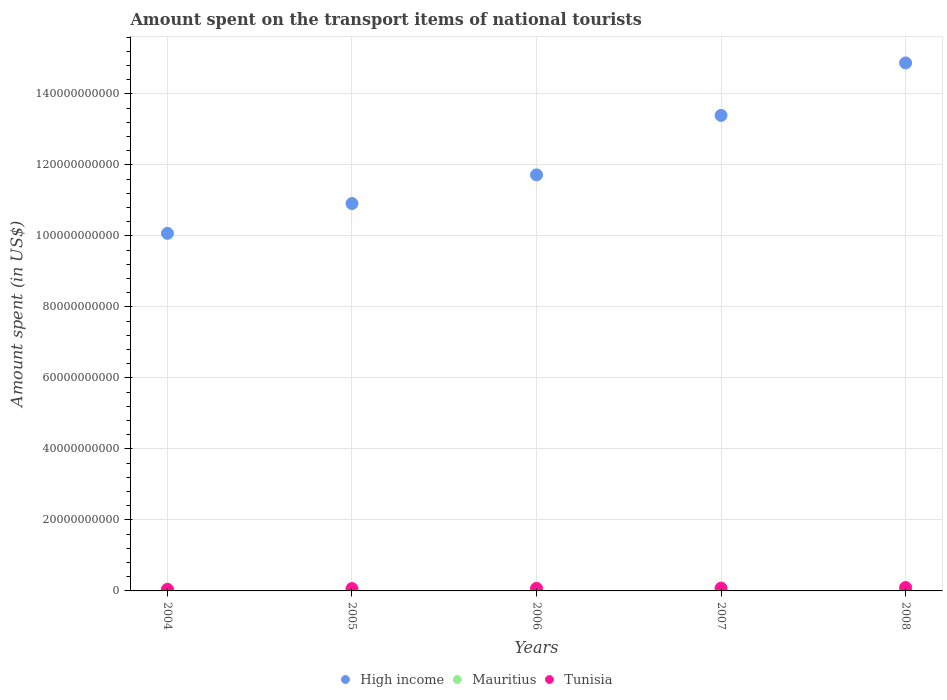How many different coloured dotlines are there?
Your answer should be compact. 3. What is the amount spent on the transport items of national tourists in Tunisia in 2007?
Provide a succinct answer. 7.98e+08. Across all years, what is the maximum amount spent on the transport items of national tourists in Tunisia?
Your response must be concise. 9.56e+08. Across all years, what is the minimum amount spent on the transport items of national tourists in High income?
Your answer should be very brief. 1.01e+11. In which year was the amount spent on the transport items of national tourists in High income maximum?
Offer a very short reply. 2008. What is the total amount spent on the transport items of national tourists in Mauritius in the graph?
Make the answer very short. 1.64e+09. What is the difference between the amount spent on the transport items of national tourists in Mauritius in 2004 and that in 2008?
Your answer should be very brief. -6.90e+07. What is the difference between the amount spent on the transport items of national tourists in Tunisia in 2006 and the amount spent on the transport items of national tourists in Mauritius in 2004?
Your response must be concise. 4.24e+08. What is the average amount spent on the transport items of national tourists in High income per year?
Provide a succinct answer. 1.22e+11. In the year 2007, what is the difference between the amount spent on the transport items of national tourists in Mauritius and amount spent on the transport items of national tourists in Tunisia?
Make the answer very short. -4.39e+08. What is the ratio of the amount spent on the transport items of national tourists in High income in 2006 to that in 2007?
Keep it short and to the point. 0.87. Is the amount spent on the transport items of national tourists in Mauritius in 2006 less than that in 2007?
Ensure brevity in your answer.  Yes. Is the difference between the amount spent on the transport items of national tourists in Mauritius in 2006 and 2007 greater than the difference between the amount spent on the transport items of national tourists in Tunisia in 2006 and 2007?
Give a very brief answer. Yes. What is the difference between the highest and the second highest amount spent on the transport items of national tourists in High income?
Your response must be concise. 1.48e+1. What is the difference between the highest and the lowest amount spent on the transport items of national tourists in Tunisia?
Provide a succinct answer. 4.94e+08. In how many years, is the amount spent on the transport items of national tourists in Mauritius greater than the average amount spent on the transport items of national tourists in Mauritius taken over all years?
Ensure brevity in your answer.  2. Is the sum of the amount spent on the transport items of national tourists in High income in 2005 and 2006 greater than the maximum amount spent on the transport items of national tourists in Tunisia across all years?
Keep it short and to the point. Yes. How many dotlines are there?
Give a very brief answer. 3. How many years are there in the graph?
Your answer should be very brief. 5. What is the difference between two consecutive major ticks on the Y-axis?
Provide a succinct answer. 2.00e+1. Are the values on the major ticks of Y-axis written in scientific E-notation?
Your response must be concise. No. Does the graph contain grids?
Offer a terse response. Yes. Where does the legend appear in the graph?
Keep it short and to the point. Bottom center. What is the title of the graph?
Give a very brief answer. Amount spent on the transport items of national tourists. Does "South Sudan" appear as one of the legend labels in the graph?
Provide a succinct answer. No. What is the label or title of the Y-axis?
Provide a succinct answer. Amount spent (in US$). What is the Amount spent (in US$) of High income in 2004?
Make the answer very short. 1.01e+11. What is the Amount spent (in US$) in Mauritius in 2004?
Give a very brief answer. 3.00e+08. What is the Amount spent (in US$) in Tunisia in 2004?
Give a very brief answer. 4.62e+08. What is the Amount spent (in US$) in High income in 2005?
Offer a very short reply. 1.09e+11. What is the Amount spent (in US$) of Mauritius in 2005?
Provide a succinct answer. 3.18e+08. What is the Amount spent (in US$) of Tunisia in 2005?
Provide a succinct answer. 6.57e+08. What is the Amount spent (in US$) of High income in 2006?
Provide a succinct answer. 1.17e+11. What is the Amount spent (in US$) in Mauritius in 2006?
Your response must be concise. 2.97e+08. What is the Amount spent (in US$) of Tunisia in 2006?
Offer a terse response. 7.24e+08. What is the Amount spent (in US$) in High income in 2007?
Keep it short and to the point. 1.34e+11. What is the Amount spent (in US$) of Mauritius in 2007?
Offer a very short reply. 3.59e+08. What is the Amount spent (in US$) of Tunisia in 2007?
Keep it short and to the point. 7.98e+08. What is the Amount spent (in US$) of High income in 2008?
Give a very brief answer. 1.49e+11. What is the Amount spent (in US$) of Mauritius in 2008?
Give a very brief answer. 3.69e+08. What is the Amount spent (in US$) in Tunisia in 2008?
Provide a short and direct response. 9.56e+08. Across all years, what is the maximum Amount spent (in US$) in High income?
Provide a short and direct response. 1.49e+11. Across all years, what is the maximum Amount spent (in US$) of Mauritius?
Your answer should be very brief. 3.69e+08. Across all years, what is the maximum Amount spent (in US$) of Tunisia?
Make the answer very short. 9.56e+08. Across all years, what is the minimum Amount spent (in US$) in High income?
Provide a succinct answer. 1.01e+11. Across all years, what is the minimum Amount spent (in US$) of Mauritius?
Your answer should be compact. 2.97e+08. Across all years, what is the minimum Amount spent (in US$) in Tunisia?
Make the answer very short. 4.62e+08. What is the total Amount spent (in US$) in High income in the graph?
Provide a succinct answer. 6.10e+11. What is the total Amount spent (in US$) of Mauritius in the graph?
Ensure brevity in your answer.  1.64e+09. What is the total Amount spent (in US$) of Tunisia in the graph?
Provide a succinct answer. 3.60e+09. What is the difference between the Amount spent (in US$) of High income in 2004 and that in 2005?
Ensure brevity in your answer.  -8.40e+09. What is the difference between the Amount spent (in US$) of Mauritius in 2004 and that in 2005?
Provide a short and direct response. -1.80e+07. What is the difference between the Amount spent (in US$) in Tunisia in 2004 and that in 2005?
Provide a succinct answer. -1.95e+08. What is the difference between the Amount spent (in US$) of High income in 2004 and that in 2006?
Provide a short and direct response. -1.65e+1. What is the difference between the Amount spent (in US$) of Mauritius in 2004 and that in 2006?
Provide a short and direct response. 3.00e+06. What is the difference between the Amount spent (in US$) in Tunisia in 2004 and that in 2006?
Your answer should be very brief. -2.62e+08. What is the difference between the Amount spent (in US$) in High income in 2004 and that in 2007?
Offer a very short reply. -3.32e+1. What is the difference between the Amount spent (in US$) in Mauritius in 2004 and that in 2007?
Keep it short and to the point. -5.90e+07. What is the difference between the Amount spent (in US$) in Tunisia in 2004 and that in 2007?
Provide a short and direct response. -3.36e+08. What is the difference between the Amount spent (in US$) of High income in 2004 and that in 2008?
Ensure brevity in your answer.  -4.80e+1. What is the difference between the Amount spent (in US$) in Mauritius in 2004 and that in 2008?
Offer a very short reply. -6.90e+07. What is the difference between the Amount spent (in US$) in Tunisia in 2004 and that in 2008?
Provide a succinct answer. -4.94e+08. What is the difference between the Amount spent (in US$) in High income in 2005 and that in 2006?
Make the answer very short. -8.07e+09. What is the difference between the Amount spent (in US$) of Mauritius in 2005 and that in 2006?
Make the answer very short. 2.10e+07. What is the difference between the Amount spent (in US$) in Tunisia in 2005 and that in 2006?
Your response must be concise. -6.70e+07. What is the difference between the Amount spent (in US$) of High income in 2005 and that in 2007?
Your answer should be compact. -2.48e+1. What is the difference between the Amount spent (in US$) in Mauritius in 2005 and that in 2007?
Your answer should be compact. -4.10e+07. What is the difference between the Amount spent (in US$) of Tunisia in 2005 and that in 2007?
Provide a short and direct response. -1.41e+08. What is the difference between the Amount spent (in US$) in High income in 2005 and that in 2008?
Give a very brief answer. -3.96e+1. What is the difference between the Amount spent (in US$) in Mauritius in 2005 and that in 2008?
Offer a terse response. -5.10e+07. What is the difference between the Amount spent (in US$) in Tunisia in 2005 and that in 2008?
Offer a terse response. -2.99e+08. What is the difference between the Amount spent (in US$) in High income in 2006 and that in 2007?
Your answer should be compact. -1.68e+1. What is the difference between the Amount spent (in US$) in Mauritius in 2006 and that in 2007?
Your response must be concise. -6.20e+07. What is the difference between the Amount spent (in US$) in Tunisia in 2006 and that in 2007?
Ensure brevity in your answer.  -7.40e+07. What is the difference between the Amount spent (in US$) of High income in 2006 and that in 2008?
Provide a short and direct response. -3.15e+1. What is the difference between the Amount spent (in US$) of Mauritius in 2006 and that in 2008?
Provide a succinct answer. -7.20e+07. What is the difference between the Amount spent (in US$) in Tunisia in 2006 and that in 2008?
Your answer should be very brief. -2.32e+08. What is the difference between the Amount spent (in US$) in High income in 2007 and that in 2008?
Offer a very short reply. -1.48e+1. What is the difference between the Amount spent (in US$) in Mauritius in 2007 and that in 2008?
Your answer should be compact. -1.00e+07. What is the difference between the Amount spent (in US$) in Tunisia in 2007 and that in 2008?
Make the answer very short. -1.58e+08. What is the difference between the Amount spent (in US$) of High income in 2004 and the Amount spent (in US$) of Mauritius in 2005?
Provide a short and direct response. 1.00e+11. What is the difference between the Amount spent (in US$) in High income in 2004 and the Amount spent (in US$) in Tunisia in 2005?
Offer a terse response. 1.00e+11. What is the difference between the Amount spent (in US$) in Mauritius in 2004 and the Amount spent (in US$) in Tunisia in 2005?
Offer a very short reply. -3.57e+08. What is the difference between the Amount spent (in US$) in High income in 2004 and the Amount spent (in US$) in Mauritius in 2006?
Give a very brief answer. 1.00e+11. What is the difference between the Amount spent (in US$) in High income in 2004 and the Amount spent (in US$) in Tunisia in 2006?
Give a very brief answer. 1.00e+11. What is the difference between the Amount spent (in US$) in Mauritius in 2004 and the Amount spent (in US$) in Tunisia in 2006?
Your answer should be compact. -4.24e+08. What is the difference between the Amount spent (in US$) of High income in 2004 and the Amount spent (in US$) of Mauritius in 2007?
Give a very brief answer. 1.00e+11. What is the difference between the Amount spent (in US$) of High income in 2004 and the Amount spent (in US$) of Tunisia in 2007?
Keep it short and to the point. 9.99e+1. What is the difference between the Amount spent (in US$) of Mauritius in 2004 and the Amount spent (in US$) of Tunisia in 2007?
Offer a very short reply. -4.98e+08. What is the difference between the Amount spent (in US$) in High income in 2004 and the Amount spent (in US$) in Mauritius in 2008?
Offer a terse response. 1.00e+11. What is the difference between the Amount spent (in US$) in High income in 2004 and the Amount spent (in US$) in Tunisia in 2008?
Give a very brief answer. 9.98e+1. What is the difference between the Amount spent (in US$) of Mauritius in 2004 and the Amount spent (in US$) of Tunisia in 2008?
Provide a succinct answer. -6.56e+08. What is the difference between the Amount spent (in US$) of High income in 2005 and the Amount spent (in US$) of Mauritius in 2006?
Your response must be concise. 1.09e+11. What is the difference between the Amount spent (in US$) of High income in 2005 and the Amount spent (in US$) of Tunisia in 2006?
Your answer should be very brief. 1.08e+11. What is the difference between the Amount spent (in US$) in Mauritius in 2005 and the Amount spent (in US$) in Tunisia in 2006?
Offer a terse response. -4.06e+08. What is the difference between the Amount spent (in US$) of High income in 2005 and the Amount spent (in US$) of Mauritius in 2007?
Provide a succinct answer. 1.09e+11. What is the difference between the Amount spent (in US$) in High income in 2005 and the Amount spent (in US$) in Tunisia in 2007?
Your response must be concise. 1.08e+11. What is the difference between the Amount spent (in US$) of Mauritius in 2005 and the Amount spent (in US$) of Tunisia in 2007?
Your answer should be compact. -4.80e+08. What is the difference between the Amount spent (in US$) of High income in 2005 and the Amount spent (in US$) of Mauritius in 2008?
Your response must be concise. 1.09e+11. What is the difference between the Amount spent (in US$) in High income in 2005 and the Amount spent (in US$) in Tunisia in 2008?
Offer a terse response. 1.08e+11. What is the difference between the Amount spent (in US$) of Mauritius in 2005 and the Amount spent (in US$) of Tunisia in 2008?
Offer a very short reply. -6.38e+08. What is the difference between the Amount spent (in US$) of High income in 2006 and the Amount spent (in US$) of Mauritius in 2007?
Ensure brevity in your answer.  1.17e+11. What is the difference between the Amount spent (in US$) of High income in 2006 and the Amount spent (in US$) of Tunisia in 2007?
Make the answer very short. 1.16e+11. What is the difference between the Amount spent (in US$) in Mauritius in 2006 and the Amount spent (in US$) in Tunisia in 2007?
Keep it short and to the point. -5.01e+08. What is the difference between the Amount spent (in US$) in High income in 2006 and the Amount spent (in US$) in Mauritius in 2008?
Give a very brief answer. 1.17e+11. What is the difference between the Amount spent (in US$) of High income in 2006 and the Amount spent (in US$) of Tunisia in 2008?
Your answer should be very brief. 1.16e+11. What is the difference between the Amount spent (in US$) in Mauritius in 2006 and the Amount spent (in US$) in Tunisia in 2008?
Make the answer very short. -6.59e+08. What is the difference between the Amount spent (in US$) of High income in 2007 and the Amount spent (in US$) of Mauritius in 2008?
Provide a short and direct response. 1.34e+11. What is the difference between the Amount spent (in US$) of High income in 2007 and the Amount spent (in US$) of Tunisia in 2008?
Offer a terse response. 1.33e+11. What is the difference between the Amount spent (in US$) of Mauritius in 2007 and the Amount spent (in US$) of Tunisia in 2008?
Give a very brief answer. -5.97e+08. What is the average Amount spent (in US$) in High income per year?
Ensure brevity in your answer.  1.22e+11. What is the average Amount spent (in US$) in Mauritius per year?
Your answer should be very brief. 3.29e+08. What is the average Amount spent (in US$) of Tunisia per year?
Ensure brevity in your answer.  7.19e+08. In the year 2004, what is the difference between the Amount spent (in US$) of High income and Amount spent (in US$) of Mauritius?
Provide a succinct answer. 1.00e+11. In the year 2004, what is the difference between the Amount spent (in US$) in High income and Amount spent (in US$) in Tunisia?
Offer a very short reply. 1.00e+11. In the year 2004, what is the difference between the Amount spent (in US$) of Mauritius and Amount spent (in US$) of Tunisia?
Your response must be concise. -1.62e+08. In the year 2005, what is the difference between the Amount spent (in US$) in High income and Amount spent (in US$) in Mauritius?
Provide a succinct answer. 1.09e+11. In the year 2005, what is the difference between the Amount spent (in US$) in High income and Amount spent (in US$) in Tunisia?
Make the answer very short. 1.08e+11. In the year 2005, what is the difference between the Amount spent (in US$) in Mauritius and Amount spent (in US$) in Tunisia?
Offer a terse response. -3.39e+08. In the year 2006, what is the difference between the Amount spent (in US$) of High income and Amount spent (in US$) of Mauritius?
Ensure brevity in your answer.  1.17e+11. In the year 2006, what is the difference between the Amount spent (in US$) in High income and Amount spent (in US$) in Tunisia?
Make the answer very short. 1.16e+11. In the year 2006, what is the difference between the Amount spent (in US$) in Mauritius and Amount spent (in US$) in Tunisia?
Your response must be concise. -4.27e+08. In the year 2007, what is the difference between the Amount spent (in US$) of High income and Amount spent (in US$) of Mauritius?
Make the answer very short. 1.34e+11. In the year 2007, what is the difference between the Amount spent (in US$) in High income and Amount spent (in US$) in Tunisia?
Your answer should be compact. 1.33e+11. In the year 2007, what is the difference between the Amount spent (in US$) of Mauritius and Amount spent (in US$) of Tunisia?
Ensure brevity in your answer.  -4.39e+08. In the year 2008, what is the difference between the Amount spent (in US$) in High income and Amount spent (in US$) in Mauritius?
Ensure brevity in your answer.  1.48e+11. In the year 2008, what is the difference between the Amount spent (in US$) in High income and Amount spent (in US$) in Tunisia?
Offer a terse response. 1.48e+11. In the year 2008, what is the difference between the Amount spent (in US$) of Mauritius and Amount spent (in US$) of Tunisia?
Offer a terse response. -5.87e+08. What is the ratio of the Amount spent (in US$) in High income in 2004 to that in 2005?
Give a very brief answer. 0.92. What is the ratio of the Amount spent (in US$) of Mauritius in 2004 to that in 2005?
Your answer should be very brief. 0.94. What is the ratio of the Amount spent (in US$) of Tunisia in 2004 to that in 2005?
Keep it short and to the point. 0.7. What is the ratio of the Amount spent (in US$) of High income in 2004 to that in 2006?
Provide a succinct answer. 0.86. What is the ratio of the Amount spent (in US$) in Mauritius in 2004 to that in 2006?
Your answer should be compact. 1.01. What is the ratio of the Amount spent (in US$) of Tunisia in 2004 to that in 2006?
Offer a terse response. 0.64. What is the ratio of the Amount spent (in US$) of High income in 2004 to that in 2007?
Provide a short and direct response. 0.75. What is the ratio of the Amount spent (in US$) of Mauritius in 2004 to that in 2007?
Your answer should be very brief. 0.84. What is the ratio of the Amount spent (in US$) in Tunisia in 2004 to that in 2007?
Provide a succinct answer. 0.58. What is the ratio of the Amount spent (in US$) of High income in 2004 to that in 2008?
Offer a terse response. 0.68. What is the ratio of the Amount spent (in US$) in Mauritius in 2004 to that in 2008?
Provide a short and direct response. 0.81. What is the ratio of the Amount spent (in US$) in Tunisia in 2004 to that in 2008?
Your answer should be very brief. 0.48. What is the ratio of the Amount spent (in US$) in High income in 2005 to that in 2006?
Keep it short and to the point. 0.93. What is the ratio of the Amount spent (in US$) in Mauritius in 2005 to that in 2006?
Provide a short and direct response. 1.07. What is the ratio of the Amount spent (in US$) of Tunisia in 2005 to that in 2006?
Make the answer very short. 0.91. What is the ratio of the Amount spent (in US$) of High income in 2005 to that in 2007?
Give a very brief answer. 0.81. What is the ratio of the Amount spent (in US$) in Mauritius in 2005 to that in 2007?
Your answer should be very brief. 0.89. What is the ratio of the Amount spent (in US$) in Tunisia in 2005 to that in 2007?
Offer a terse response. 0.82. What is the ratio of the Amount spent (in US$) in High income in 2005 to that in 2008?
Make the answer very short. 0.73. What is the ratio of the Amount spent (in US$) of Mauritius in 2005 to that in 2008?
Your response must be concise. 0.86. What is the ratio of the Amount spent (in US$) in Tunisia in 2005 to that in 2008?
Give a very brief answer. 0.69. What is the ratio of the Amount spent (in US$) of High income in 2006 to that in 2007?
Keep it short and to the point. 0.87. What is the ratio of the Amount spent (in US$) of Mauritius in 2006 to that in 2007?
Give a very brief answer. 0.83. What is the ratio of the Amount spent (in US$) of Tunisia in 2006 to that in 2007?
Keep it short and to the point. 0.91. What is the ratio of the Amount spent (in US$) of High income in 2006 to that in 2008?
Your response must be concise. 0.79. What is the ratio of the Amount spent (in US$) of Mauritius in 2006 to that in 2008?
Provide a succinct answer. 0.8. What is the ratio of the Amount spent (in US$) of Tunisia in 2006 to that in 2008?
Provide a succinct answer. 0.76. What is the ratio of the Amount spent (in US$) in High income in 2007 to that in 2008?
Your answer should be very brief. 0.9. What is the ratio of the Amount spent (in US$) in Mauritius in 2007 to that in 2008?
Provide a succinct answer. 0.97. What is the ratio of the Amount spent (in US$) of Tunisia in 2007 to that in 2008?
Your response must be concise. 0.83. What is the difference between the highest and the second highest Amount spent (in US$) of High income?
Make the answer very short. 1.48e+1. What is the difference between the highest and the second highest Amount spent (in US$) in Tunisia?
Keep it short and to the point. 1.58e+08. What is the difference between the highest and the lowest Amount spent (in US$) of High income?
Give a very brief answer. 4.80e+1. What is the difference between the highest and the lowest Amount spent (in US$) in Mauritius?
Provide a succinct answer. 7.20e+07. What is the difference between the highest and the lowest Amount spent (in US$) in Tunisia?
Offer a terse response. 4.94e+08. 